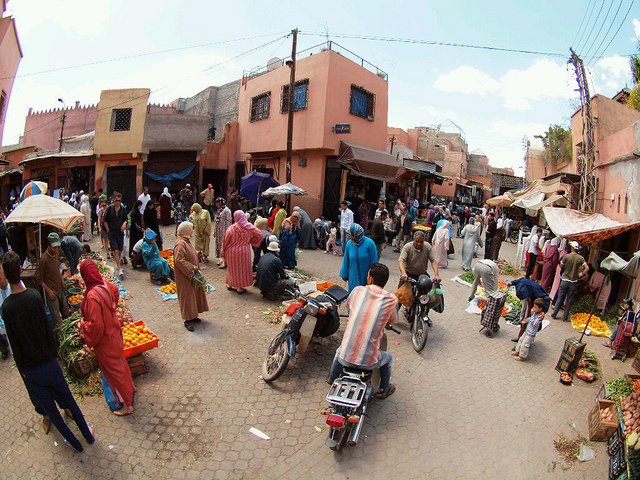<image>Is this a carnival? No, this may not be a carnival. Is this a carnival? This is not a carnival. 